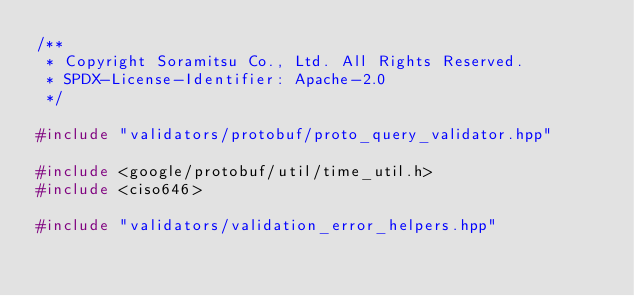Convert code to text. <code><loc_0><loc_0><loc_500><loc_500><_C++_>/**
 * Copyright Soramitsu Co., Ltd. All Rights Reserved.
 * SPDX-License-Identifier: Apache-2.0
 */

#include "validators/protobuf/proto_query_validator.hpp"

#include <google/protobuf/util/time_util.h>
#include <ciso646>

#include "validators/validation_error_helpers.hpp"</code> 